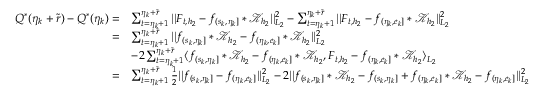<formula> <loc_0><loc_0><loc_500><loc_500>\begin{array} { r l } { Q ^ { * } ( \eta _ { k } + \widetilde { r } ) - Q ^ { * } ( \eta _ { k } ) = } & { \sum _ { t = \eta _ { k } + 1 } ^ { \eta _ { k } + \widetilde { r } } | | F _ { t , { h _ { 2 } } } - f _ { ( s _ { k } , \eta _ { k } ] } \ast \mathcal { K } _ { { h _ { 2 } } } | | _ { L _ { 2 } } ^ { 2 } - \sum _ { t = \eta _ { k } + 1 } ^ { \eta _ { k } + \widetilde { r } } | | F _ { t , { h _ { 2 } } } - f _ { ( \eta _ { k } , e _ { k } ] } \ast \mathcal { K } _ { h _ { 2 } } | | _ { L _ { 2 } } ^ { 2 } } \\ { = } & { \sum _ { t = \eta _ { k } + 1 } ^ { \eta _ { k } + \widetilde { r } } | | f _ { ( s _ { k } , \eta _ { k } ] } \ast \mathcal { K } _ { { h _ { 2 } } } - f _ { ( \eta _ { k } , e _ { k } ] } \ast \mathcal { K } _ { h _ { 2 } } | | _ { L _ { 2 } } ^ { 2 } } \\ & { - 2 \sum _ { t = \eta _ { k } + 1 } ^ { \eta _ { k } + \widetilde { r } } \langle f _ { ( s _ { k } , \eta _ { k } ] } \ast \mathcal { K } _ { { h _ { 2 } } } - f _ { ( \eta _ { k } , e _ { k } ] } \ast \mathcal { K } _ { h _ { 2 } } , F _ { t , { h _ { 2 } } } - f _ { ( \eta _ { k } , e _ { k } ] } \ast \mathcal { K } _ { h _ { 2 } } \rangle _ { L _ { 2 } } } \\ { = } & { \sum _ { t = \eta _ { k } + 1 } ^ { \eta _ { k } + \widetilde { r } } \frac { 1 } { 2 } | | f _ { ( s _ { k } , \eta _ { k } ] } - f _ { ( \eta _ { k } , e _ { k } ] } | | _ { L _ { 2 } } ^ { 2 } - 2 | | f _ { ( s _ { k } , \eta _ { k } ] } \ast \mathcal { K } _ { { h _ { 2 } } } - f _ { ( s _ { k } , \eta _ { k } ] } + f _ { ( \eta _ { k } , e _ { k } ] } \ast \mathcal { K } _ { h _ { 2 } } - f _ { ( \eta _ { k } , e _ { k } ] } | | _ { L _ { 2 } } ^ { 2 } } \end{array}</formula> 